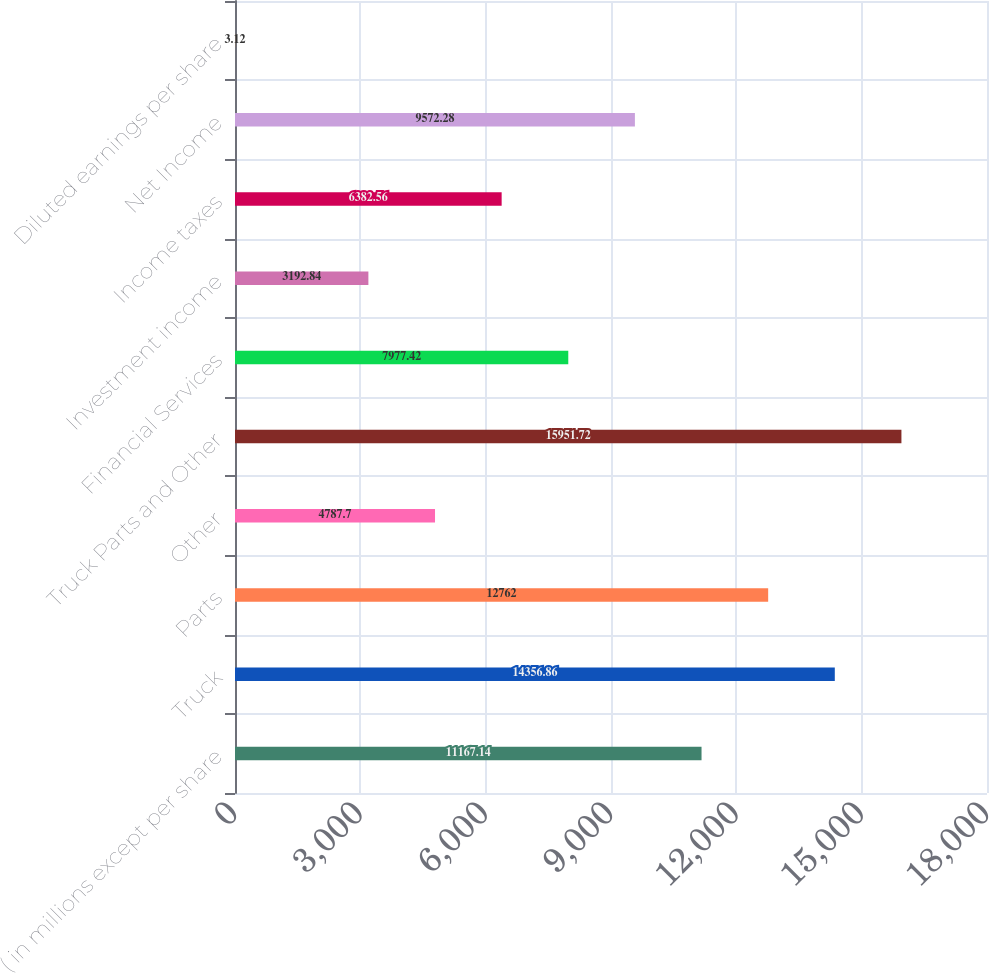<chart> <loc_0><loc_0><loc_500><loc_500><bar_chart><fcel>( in millions except per share<fcel>Truck<fcel>Parts<fcel>Other<fcel>Truck Parts and Other<fcel>Financial Services<fcel>Investment income<fcel>Income taxes<fcel>Net Income<fcel>Diluted earnings per share<nl><fcel>11167.1<fcel>14356.9<fcel>12762<fcel>4787.7<fcel>15951.7<fcel>7977.42<fcel>3192.84<fcel>6382.56<fcel>9572.28<fcel>3.12<nl></chart> 